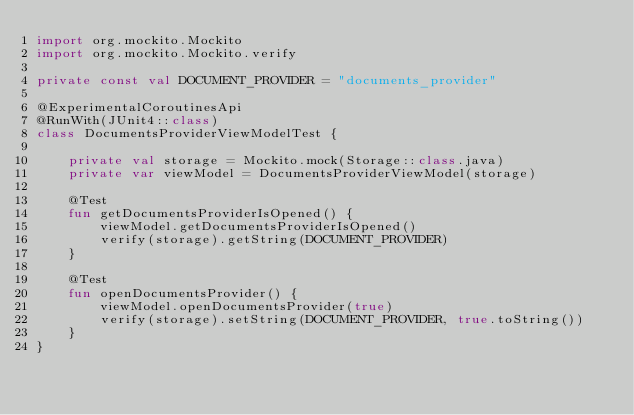<code> <loc_0><loc_0><loc_500><loc_500><_Kotlin_>import org.mockito.Mockito
import org.mockito.Mockito.verify

private const val DOCUMENT_PROVIDER = "documents_provider"

@ExperimentalCoroutinesApi
@RunWith(JUnit4::class)
class DocumentsProviderViewModelTest {

    private val storage = Mockito.mock(Storage::class.java)
    private var viewModel = DocumentsProviderViewModel(storage)

    @Test
    fun getDocumentsProviderIsOpened() {
        viewModel.getDocumentsProviderIsOpened()
        verify(storage).getString(DOCUMENT_PROVIDER)
    }

    @Test
    fun openDocumentsProvider() {
        viewModel.openDocumentsProvider(true)
        verify(storage).setString(DOCUMENT_PROVIDER, true.toString())
    }
}</code> 